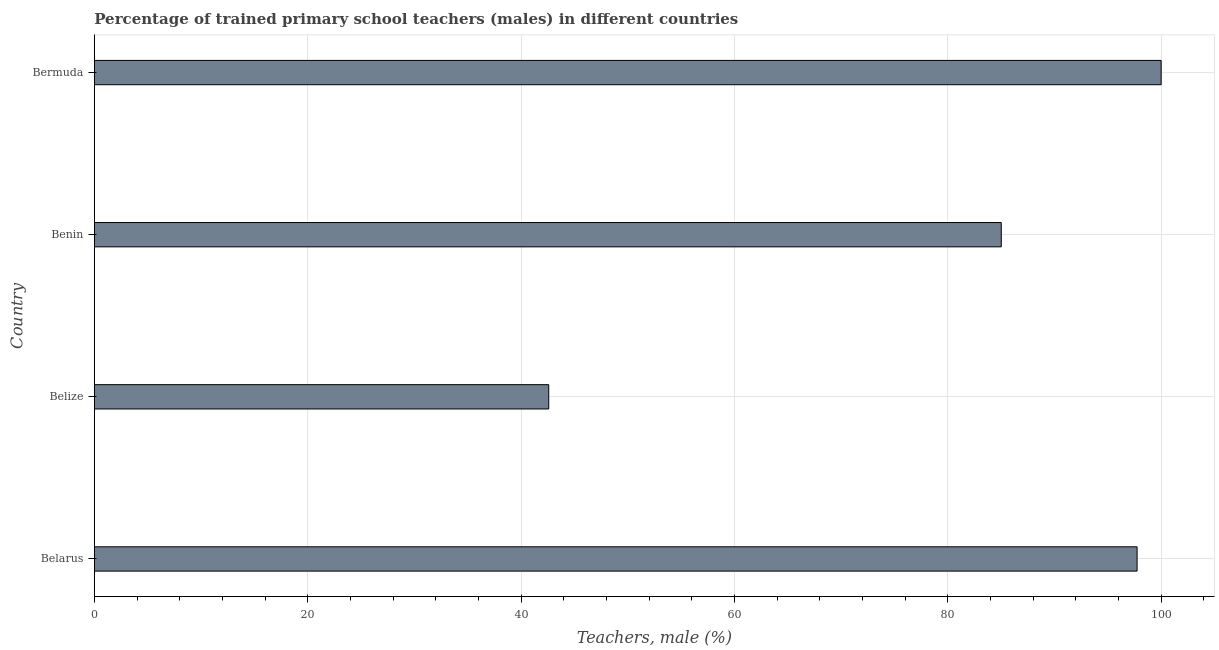Does the graph contain any zero values?
Keep it short and to the point. No. Does the graph contain grids?
Provide a short and direct response. Yes. What is the title of the graph?
Your response must be concise. Percentage of trained primary school teachers (males) in different countries. What is the label or title of the X-axis?
Your answer should be very brief. Teachers, male (%). What is the percentage of trained male teachers in Belarus?
Provide a succinct answer. 97.74. Across all countries, what is the maximum percentage of trained male teachers?
Give a very brief answer. 100. Across all countries, what is the minimum percentage of trained male teachers?
Keep it short and to the point. 42.59. In which country was the percentage of trained male teachers maximum?
Make the answer very short. Bermuda. In which country was the percentage of trained male teachers minimum?
Provide a short and direct response. Belize. What is the sum of the percentage of trained male teachers?
Make the answer very short. 325.35. What is the difference between the percentage of trained male teachers in Belize and Benin?
Make the answer very short. -42.42. What is the average percentage of trained male teachers per country?
Ensure brevity in your answer.  81.34. What is the median percentage of trained male teachers?
Ensure brevity in your answer.  91.38. In how many countries, is the percentage of trained male teachers greater than 60 %?
Your answer should be very brief. 3. What is the ratio of the percentage of trained male teachers in Belize to that in Bermuda?
Offer a very short reply. 0.43. Is the percentage of trained male teachers in Benin less than that in Bermuda?
Offer a terse response. Yes. Is the difference between the percentage of trained male teachers in Belize and Bermuda greater than the difference between any two countries?
Provide a short and direct response. Yes. What is the difference between the highest and the second highest percentage of trained male teachers?
Ensure brevity in your answer.  2.26. What is the difference between the highest and the lowest percentage of trained male teachers?
Make the answer very short. 57.41. What is the difference between two consecutive major ticks on the X-axis?
Make the answer very short. 20. What is the Teachers, male (%) in Belarus?
Offer a very short reply. 97.74. What is the Teachers, male (%) of Belize?
Provide a succinct answer. 42.59. What is the Teachers, male (%) of Benin?
Provide a succinct answer. 85.01. What is the difference between the Teachers, male (%) in Belarus and Belize?
Your answer should be very brief. 55.15. What is the difference between the Teachers, male (%) in Belarus and Benin?
Provide a short and direct response. 12.73. What is the difference between the Teachers, male (%) in Belarus and Bermuda?
Your response must be concise. -2.26. What is the difference between the Teachers, male (%) in Belize and Benin?
Your response must be concise. -42.42. What is the difference between the Teachers, male (%) in Belize and Bermuda?
Offer a very short reply. -57.41. What is the difference between the Teachers, male (%) in Benin and Bermuda?
Give a very brief answer. -14.99. What is the ratio of the Teachers, male (%) in Belarus to that in Belize?
Provide a short and direct response. 2.29. What is the ratio of the Teachers, male (%) in Belarus to that in Benin?
Your response must be concise. 1.15. What is the ratio of the Teachers, male (%) in Belarus to that in Bermuda?
Offer a very short reply. 0.98. What is the ratio of the Teachers, male (%) in Belize to that in Benin?
Your answer should be compact. 0.5. What is the ratio of the Teachers, male (%) in Belize to that in Bermuda?
Provide a succinct answer. 0.43. 